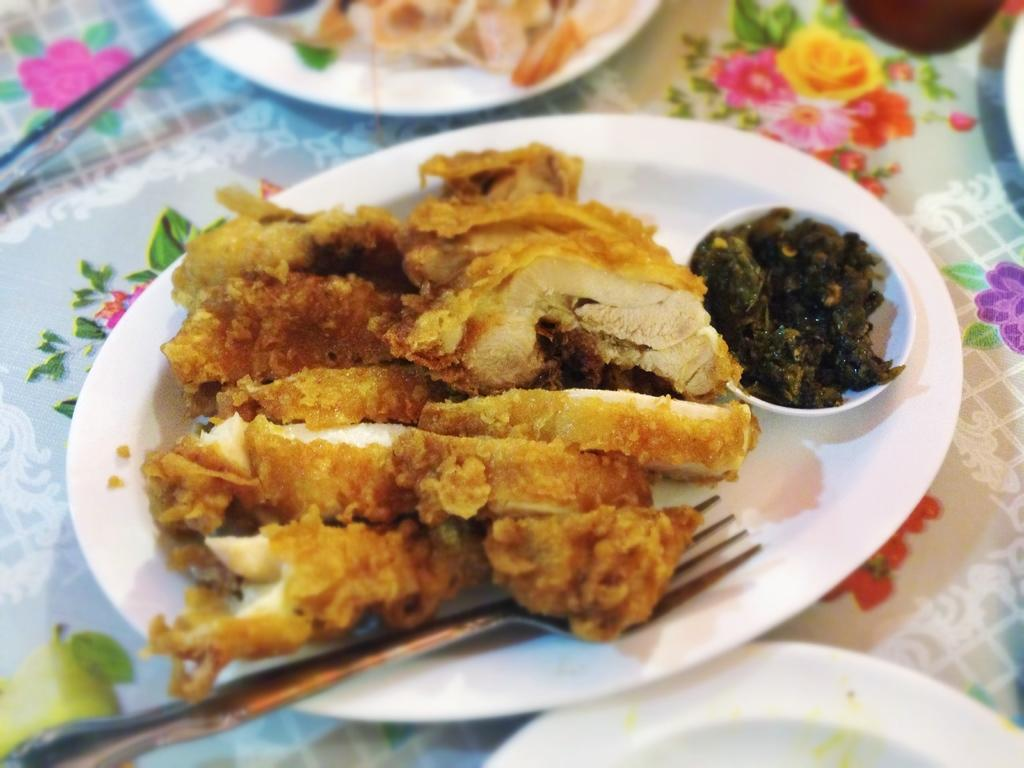What is on the plates that are visible in the image? There are plates containing food in the image. What utensil can be seen in the image? A spoon is visible in the image. What other utensil is present in the image? A fork is present in the image. Where are the plates, spoon, and fork located in the image? The plates, spoon, and fork are placed on a surface. What type of argument is taking place between the plates in the image? There is no argument taking place in the image; it only shows plates containing food, a spoon, and a fork. Can you tell me how many clams are on the plates in the image? There is no mention of clams in the image; it only shows plates containing food. 